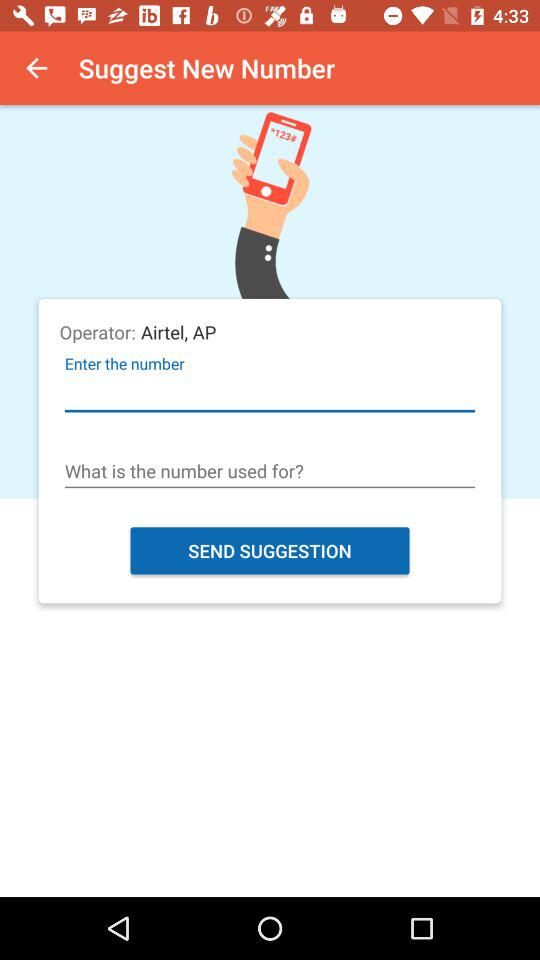What is the name of the operator? The name of the operator is "Airtel, AP". 